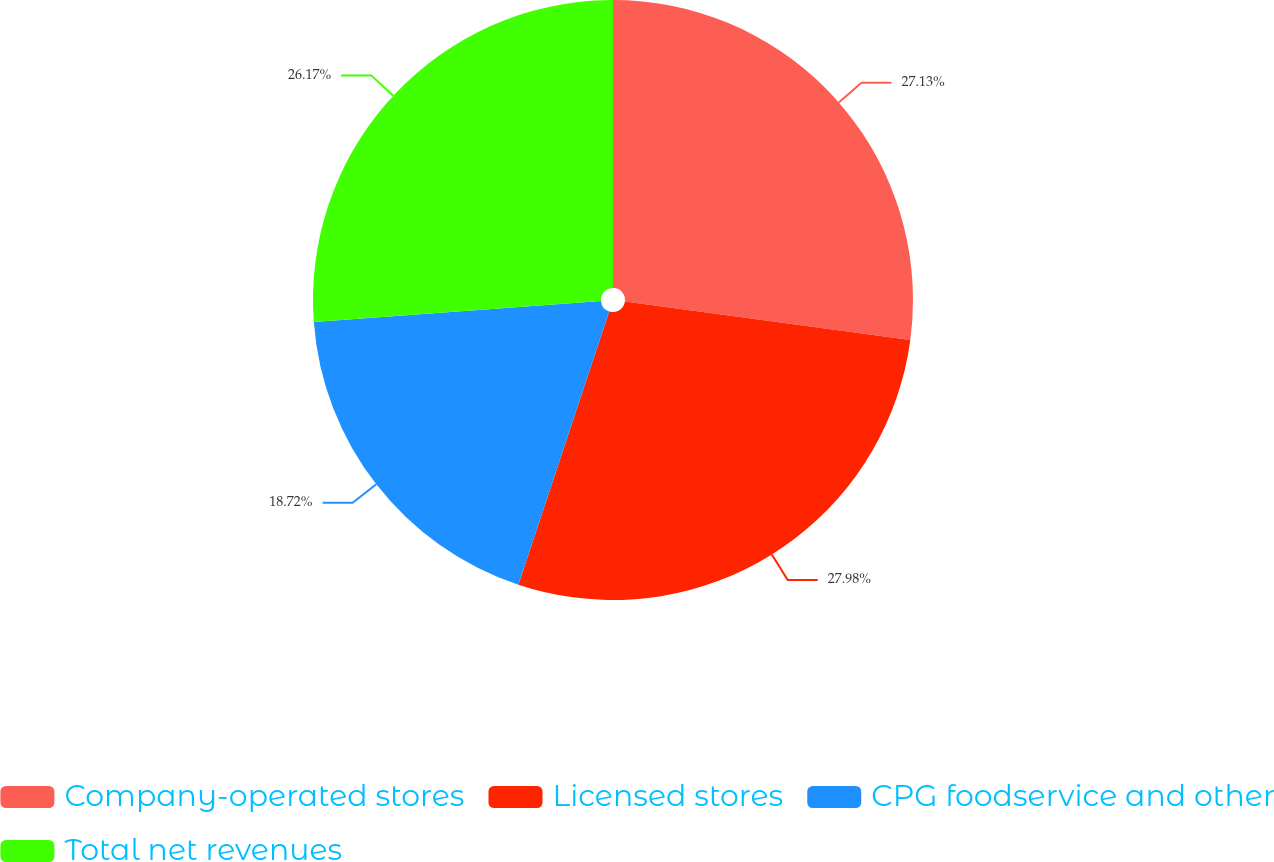Convert chart to OTSL. <chart><loc_0><loc_0><loc_500><loc_500><pie_chart><fcel>Company-operated stores<fcel>Licensed stores<fcel>CPG foodservice and other<fcel>Total net revenues<nl><fcel>27.13%<fcel>27.98%<fcel>18.72%<fcel>26.17%<nl></chart> 